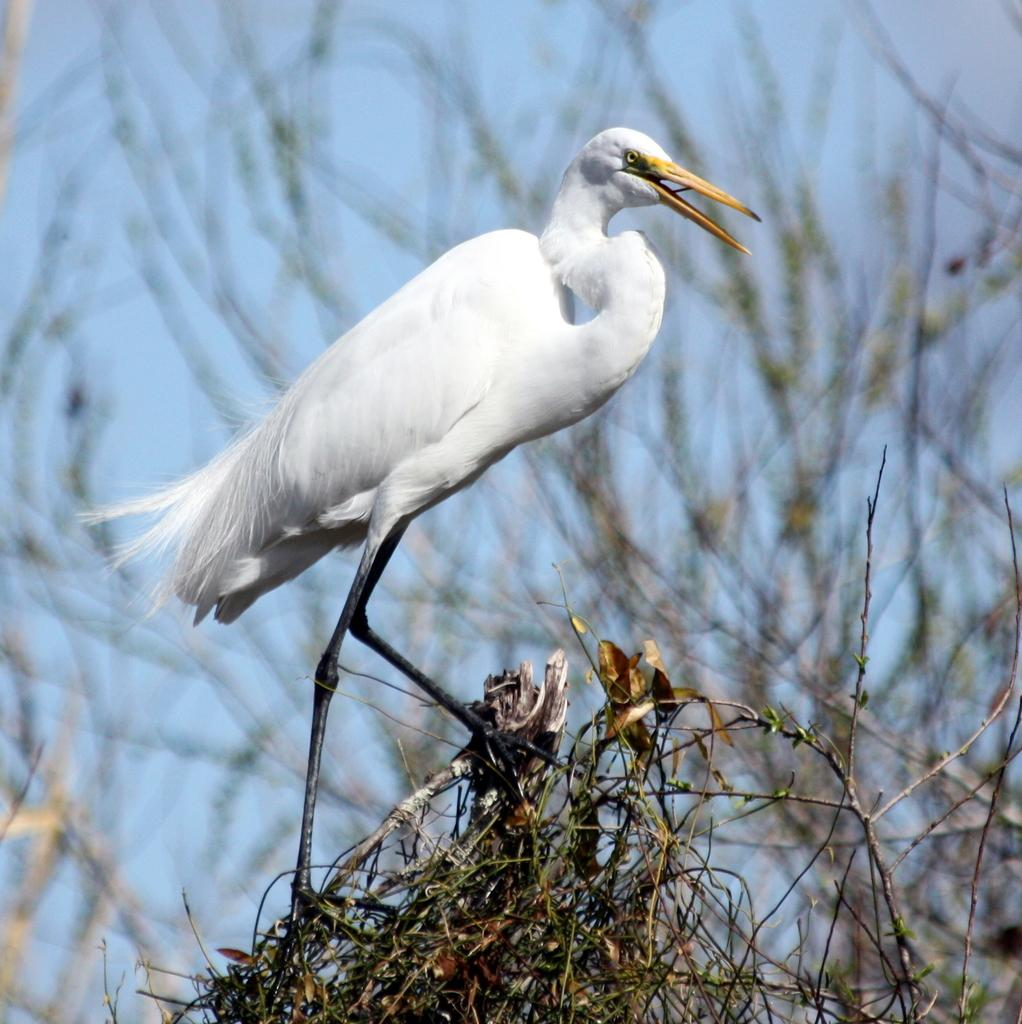What type of animal is standing in the image? There is a bird standing in the image. What else can be seen in the image besides the bird? There are stems visible in the image. Can you describe the background of the image? The background appears blurry in the image. How many rabbits can be seen playing with the ladybug in the image? There are no rabbits or ladybugs present in the image. 